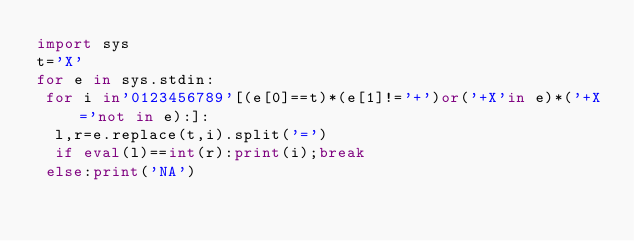Convert code to text. <code><loc_0><loc_0><loc_500><loc_500><_Python_>import sys
t='X'
for e in sys.stdin:
 for i in'0123456789'[(e[0]==t)*(e[1]!='+')or('+X'in e)*('+X='not in e):]:
  l,r=e.replace(t,i).split('=')
  if eval(l)==int(r):print(i);break
 else:print('NA')
</code> 